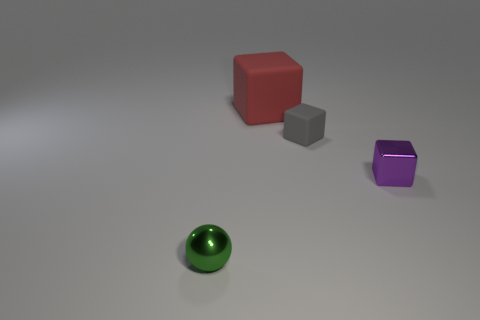There is a tiny rubber block; is it the same color as the metal object that is behind the small sphere?
Provide a short and direct response. No. How many things are purple blocks or metallic cylinders?
Provide a short and direct response. 1. Is there anything else that is the same color as the tiny shiny ball?
Offer a very short reply. No. Is the material of the tiny ball the same as the tiny block that is on the left side of the tiny purple thing?
Provide a short and direct response. No. There is a small metal object that is in front of the metallic thing that is on the right side of the small green ball; what shape is it?
Offer a very short reply. Sphere. What is the shape of the thing that is both to the left of the small gray rubber thing and behind the small green thing?
Make the answer very short. Cube. What number of things are purple cubes or tiny things that are behind the tiny green metallic ball?
Give a very brief answer. 2. There is a big thing that is the same shape as the small matte thing; what material is it?
Offer a very short reply. Rubber. Is there any other thing that has the same material as the gray cube?
Offer a terse response. Yes. What material is the thing that is both on the right side of the red cube and in front of the tiny rubber object?
Your answer should be very brief. Metal. 